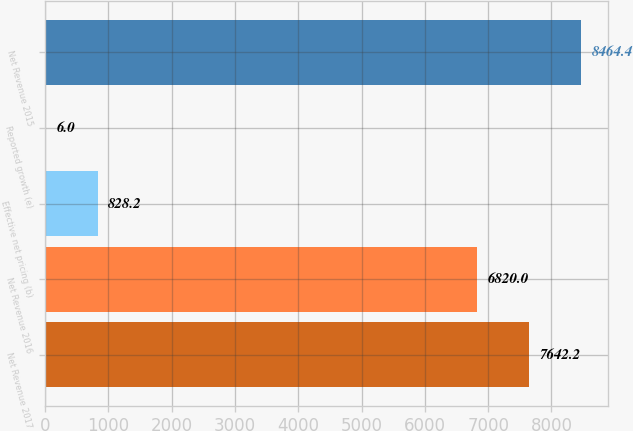Convert chart. <chart><loc_0><loc_0><loc_500><loc_500><bar_chart><fcel>Net Revenue 2017<fcel>Net Revenue 2016<fcel>Effective net pricing (b)<fcel>Reported growth (e)<fcel>Net Revenue 2015<nl><fcel>7642.2<fcel>6820<fcel>828.2<fcel>6<fcel>8464.4<nl></chart> 